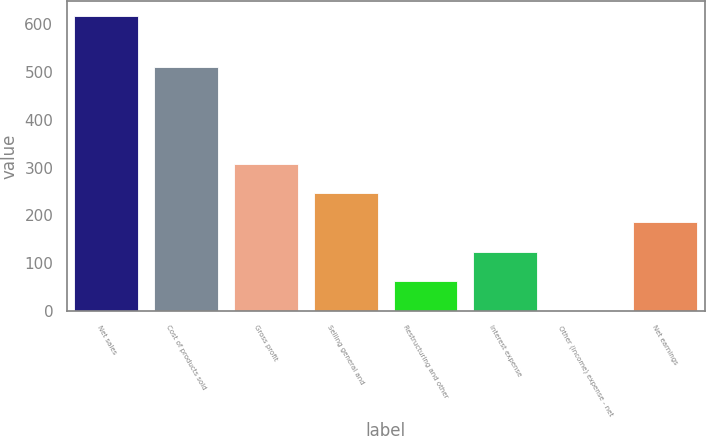Convert chart. <chart><loc_0><loc_0><loc_500><loc_500><bar_chart><fcel>Net sales<fcel>Cost of products sold<fcel>Gross profit<fcel>Selling general and<fcel>Restructuring and other<fcel>Interest expense<fcel>Other (income) expense - net<fcel>Net earnings<nl><fcel>616.5<fcel>510.5<fcel>308.4<fcel>246.78<fcel>61.92<fcel>123.54<fcel>0.3<fcel>185.16<nl></chart> 